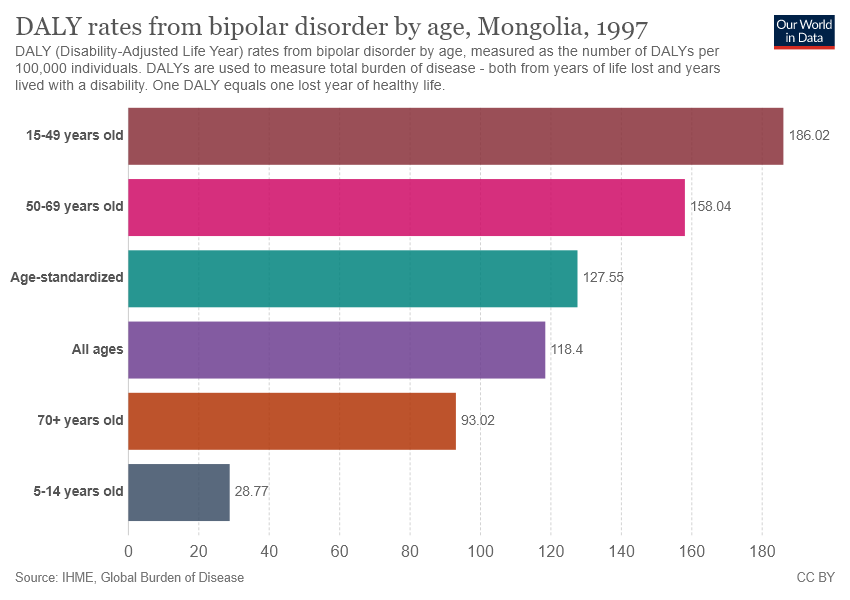Give some essential details in this illustration. The sum of the smallest two bars is not equal to the value of the second largest bar. The value of the longest bar is 186.02. 